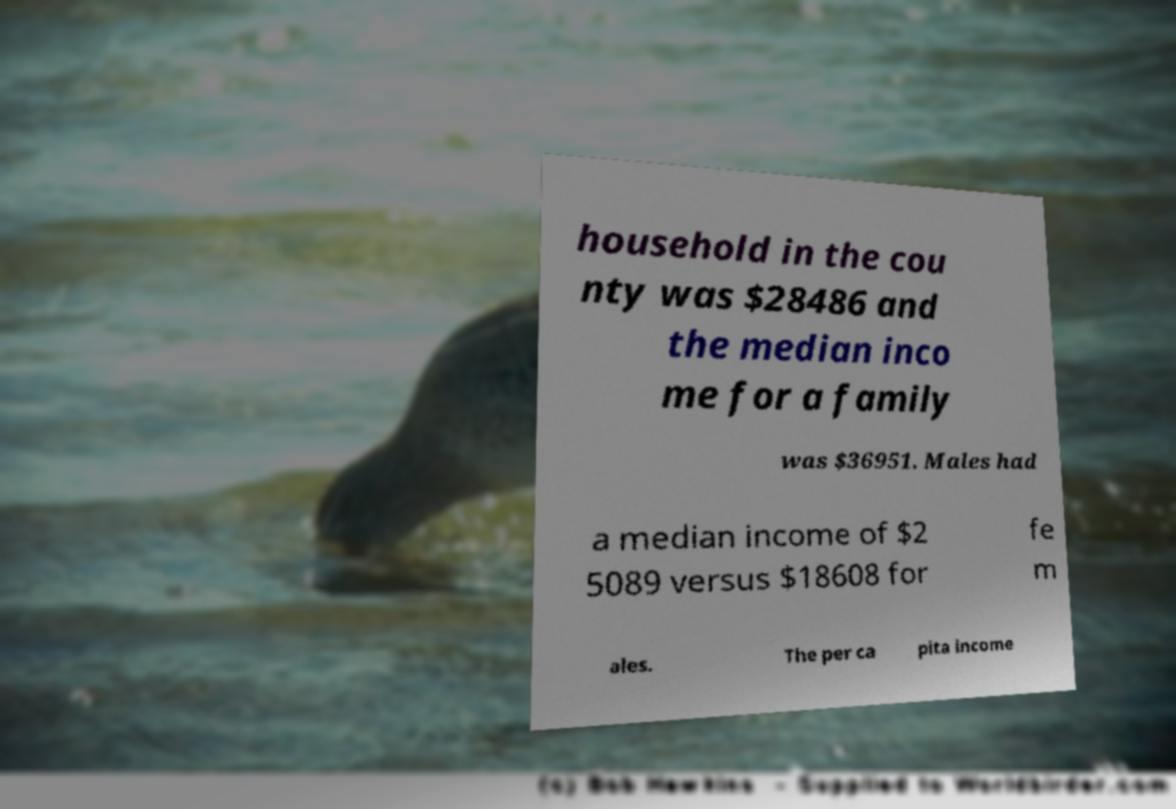Can you read and provide the text displayed in the image?This photo seems to have some interesting text. Can you extract and type it out for me? household in the cou nty was $28486 and the median inco me for a family was $36951. Males had a median income of $2 5089 versus $18608 for fe m ales. The per ca pita income 